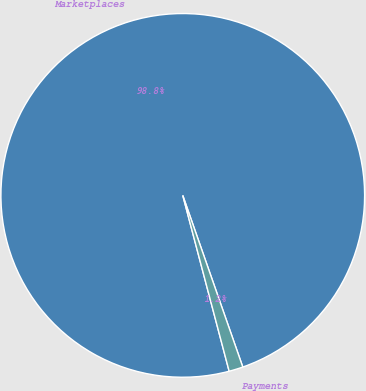<chart> <loc_0><loc_0><loc_500><loc_500><pie_chart><fcel>Marketplaces<fcel>Payments<nl><fcel>98.75%<fcel>1.25%<nl></chart> 